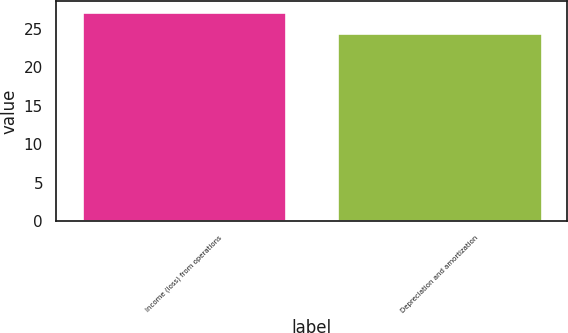<chart> <loc_0><loc_0><loc_500><loc_500><bar_chart><fcel>Income (loss) from operations<fcel>Depreciation and amortization<nl><fcel>27.2<fcel>24.4<nl></chart> 